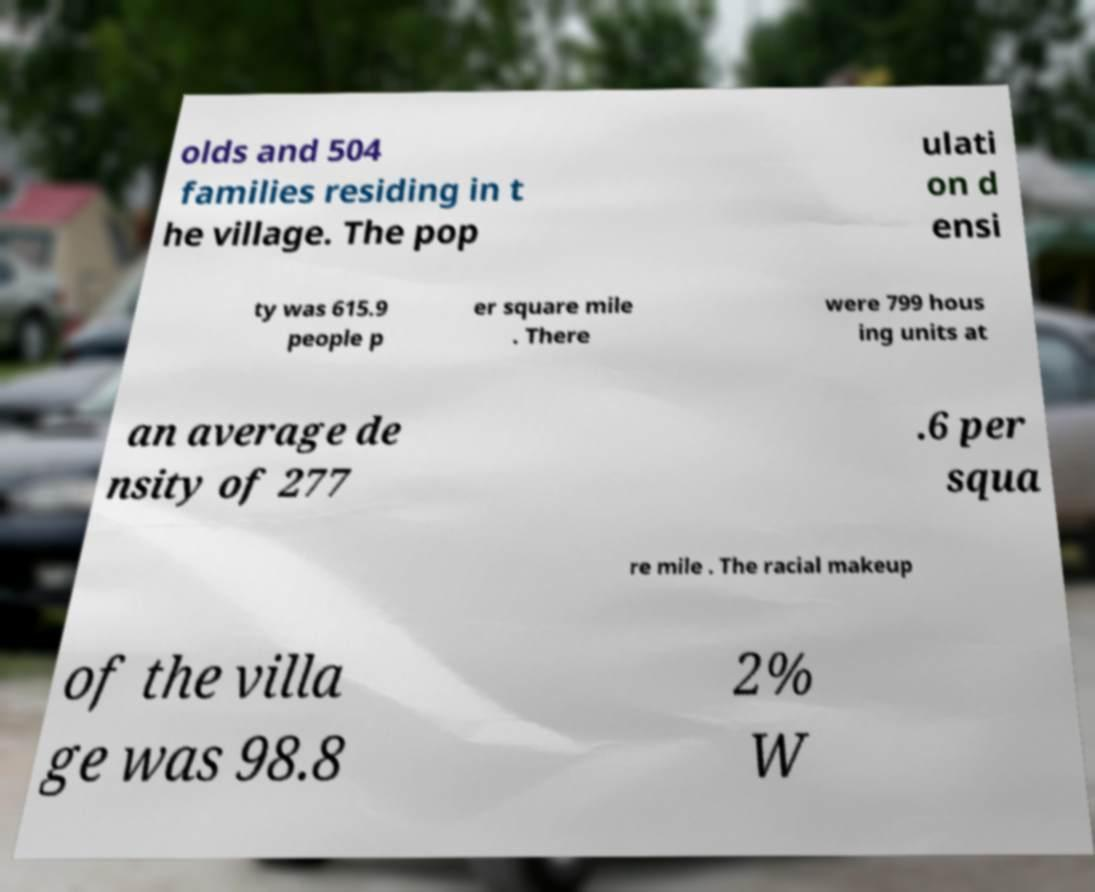Can you accurately transcribe the text from the provided image for me? olds and 504 families residing in t he village. The pop ulati on d ensi ty was 615.9 people p er square mile . There were 799 hous ing units at an average de nsity of 277 .6 per squa re mile . The racial makeup of the villa ge was 98.8 2% W 